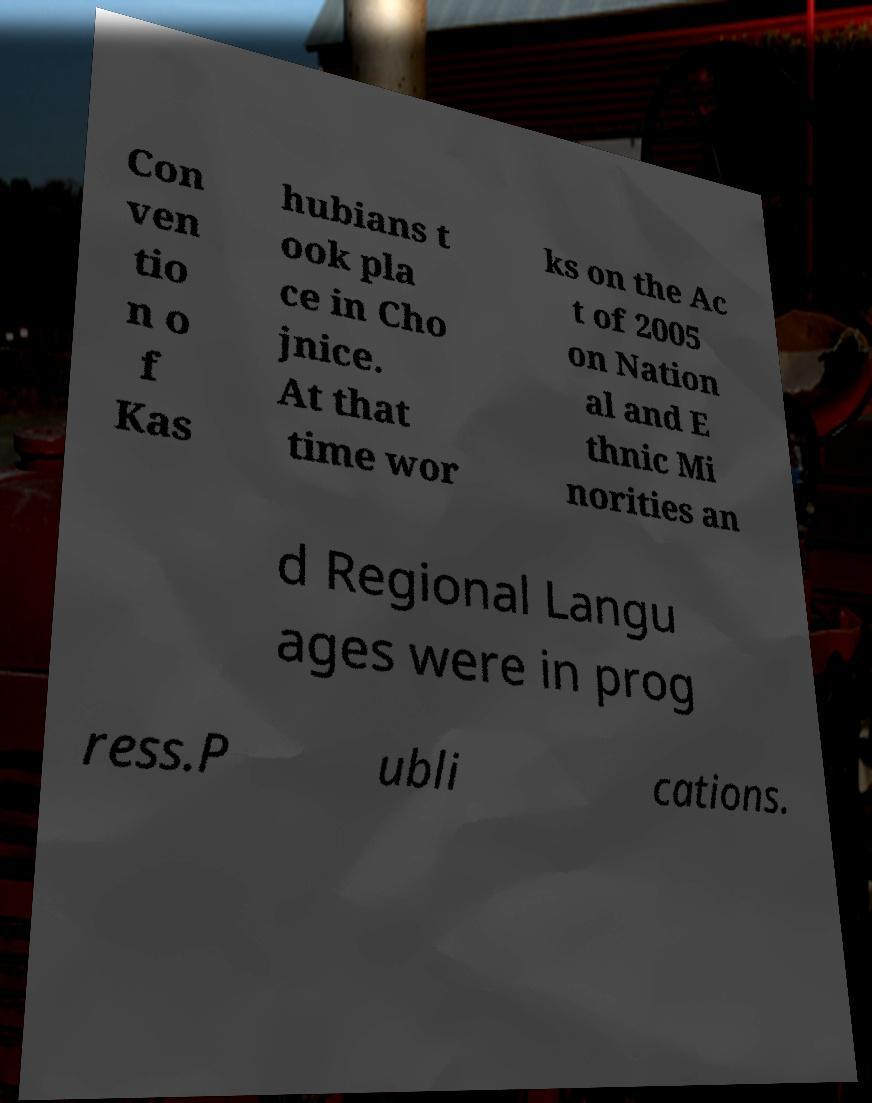Could you extract and type out the text from this image? Con ven tio n o f Kas hubians t ook pla ce in Cho jnice. At that time wor ks on the Ac t of 2005 on Nation al and E thnic Mi norities an d Regional Langu ages were in prog ress.P ubli cations. 